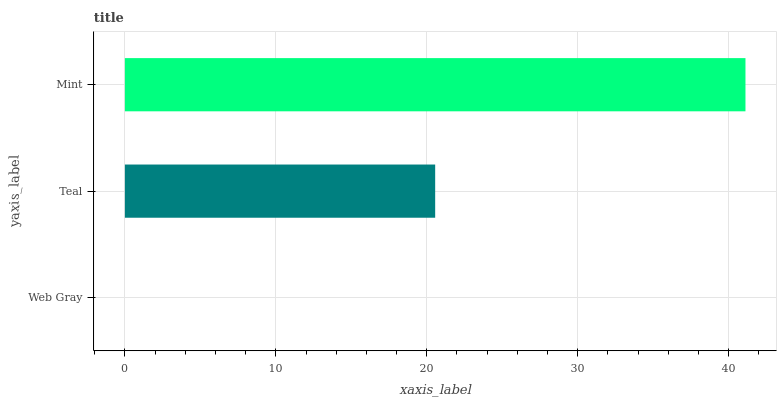Is Web Gray the minimum?
Answer yes or no. Yes. Is Mint the maximum?
Answer yes or no. Yes. Is Teal the minimum?
Answer yes or no. No. Is Teal the maximum?
Answer yes or no. No. Is Teal greater than Web Gray?
Answer yes or no. Yes. Is Web Gray less than Teal?
Answer yes or no. Yes. Is Web Gray greater than Teal?
Answer yes or no. No. Is Teal less than Web Gray?
Answer yes or no. No. Is Teal the high median?
Answer yes or no. Yes. Is Teal the low median?
Answer yes or no. Yes. Is Mint the high median?
Answer yes or no. No. Is Web Gray the low median?
Answer yes or no. No. 